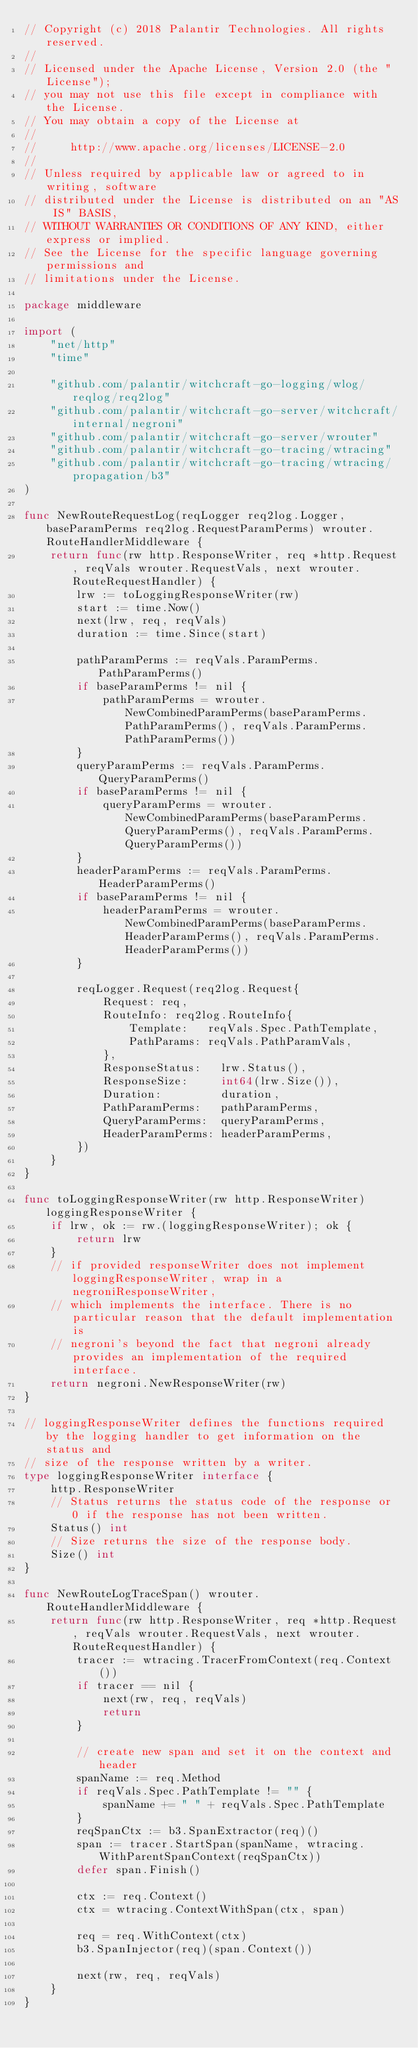Convert code to text. <code><loc_0><loc_0><loc_500><loc_500><_Go_>// Copyright (c) 2018 Palantir Technologies. All rights reserved.
//
// Licensed under the Apache License, Version 2.0 (the "License");
// you may not use this file except in compliance with the License.
// You may obtain a copy of the License at
//
//     http://www.apache.org/licenses/LICENSE-2.0
//
// Unless required by applicable law or agreed to in writing, software
// distributed under the License is distributed on an "AS IS" BASIS,
// WITHOUT WARRANTIES OR CONDITIONS OF ANY KIND, either express or implied.
// See the License for the specific language governing permissions and
// limitations under the License.

package middleware

import (
	"net/http"
	"time"

	"github.com/palantir/witchcraft-go-logging/wlog/reqlog/req2log"
	"github.com/palantir/witchcraft-go-server/witchcraft/internal/negroni"
	"github.com/palantir/witchcraft-go-server/wrouter"
	"github.com/palantir/witchcraft-go-tracing/wtracing"
	"github.com/palantir/witchcraft-go-tracing/wtracing/propagation/b3"
)

func NewRouteRequestLog(reqLogger req2log.Logger, baseParamPerms req2log.RequestParamPerms) wrouter.RouteHandlerMiddleware {
	return func(rw http.ResponseWriter, req *http.Request, reqVals wrouter.RequestVals, next wrouter.RouteRequestHandler) {
		lrw := toLoggingResponseWriter(rw)
		start := time.Now()
		next(lrw, req, reqVals)
		duration := time.Since(start)

		pathParamPerms := reqVals.ParamPerms.PathParamPerms()
		if baseParamPerms != nil {
			pathParamPerms = wrouter.NewCombinedParamPerms(baseParamPerms.PathParamPerms(), reqVals.ParamPerms.PathParamPerms())
		}
		queryParamPerms := reqVals.ParamPerms.QueryParamPerms()
		if baseParamPerms != nil {
			queryParamPerms = wrouter.NewCombinedParamPerms(baseParamPerms.QueryParamPerms(), reqVals.ParamPerms.QueryParamPerms())
		}
		headerParamPerms := reqVals.ParamPerms.HeaderParamPerms()
		if baseParamPerms != nil {
			headerParamPerms = wrouter.NewCombinedParamPerms(baseParamPerms.HeaderParamPerms(), reqVals.ParamPerms.HeaderParamPerms())
		}

		reqLogger.Request(req2log.Request{
			Request: req,
			RouteInfo: req2log.RouteInfo{
				Template:   reqVals.Spec.PathTemplate,
				PathParams: reqVals.PathParamVals,
			},
			ResponseStatus:   lrw.Status(),
			ResponseSize:     int64(lrw.Size()),
			Duration:         duration,
			PathParamPerms:   pathParamPerms,
			QueryParamPerms:  queryParamPerms,
			HeaderParamPerms: headerParamPerms,
		})
	}
}

func toLoggingResponseWriter(rw http.ResponseWriter) loggingResponseWriter {
	if lrw, ok := rw.(loggingResponseWriter); ok {
		return lrw
	}
	// if provided responseWriter does not implement loggingResponseWriter, wrap in a negroniResponseWriter,
	// which implements the interface. There is no particular reason that the default implementation is
	// negroni's beyond the fact that negroni already provides an implementation of the required interface.
	return negroni.NewResponseWriter(rw)
}

// loggingResponseWriter defines the functions required by the logging handler to get information on the status and
// size of the response written by a writer.
type loggingResponseWriter interface {
	http.ResponseWriter
	// Status returns the status code of the response or 0 if the response has not been written.
	Status() int
	// Size returns the size of the response body.
	Size() int
}

func NewRouteLogTraceSpan() wrouter.RouteHandlerMiddleware {
	return func(rw http.ResponseWriter, req *http.Request, reqVals wrouter.RequestVals, next wrouter.RouteRequestHandler) {
		tracer := wtracing.TracerFromContext(req.Context())
		if tracer == nil {
			next(rw, req, reqVals)
			return
		}

		// create new span and set it on the context and header
		spanName := req.Method
		if reqVals.Spec.PathTemplate != "" {
			spanName += " " + reqVals.Spec.PathTemplate
		}
		reqSpanCtx := b3.SpanExtractor(req)()
		span := tracer.StartSpan(spanName, wtracing.WithParentSpanContext(reqSpanCtx))
		defer span.Finish()

		ctx := req.Context()
		ctx = wtracing.ContextWithSpan(ctx, span)

		req = req.WithContext(ctx)
		b3.SpanInjector(req)(span.Context())

		next(rw, req, reqVals)
	}
}
</code> 